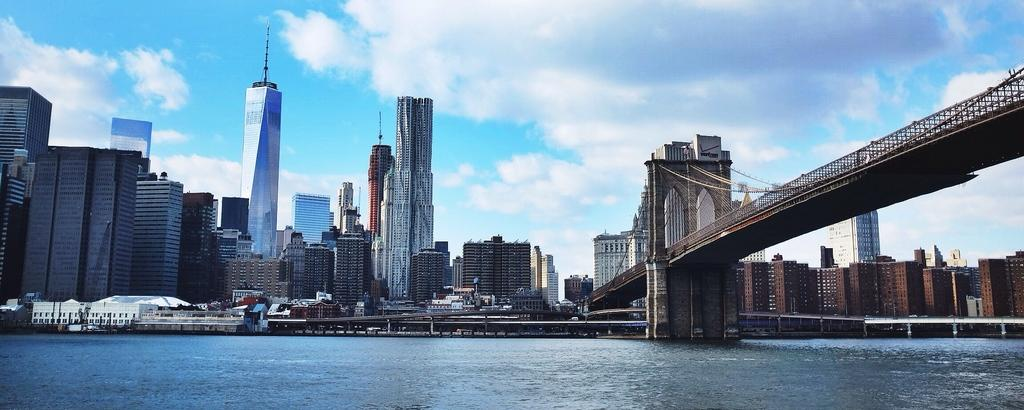What is the main feature of the image? There is a water body in the image. What is built over the water body? There is a bridge over the water body. How is the bridge supported? The bridge has pillars. What type of material is used for the bridge? The bridge has ropes. What can be seen in the distance in the image? There are buildings visible in the background. How would you describe the weather in the image? The sky is cloudy in the image. What type of cloth is being used to wrap the wrist of the person in the image? There is no person present in the image, and therefore no wrist or cloth can be observed. 